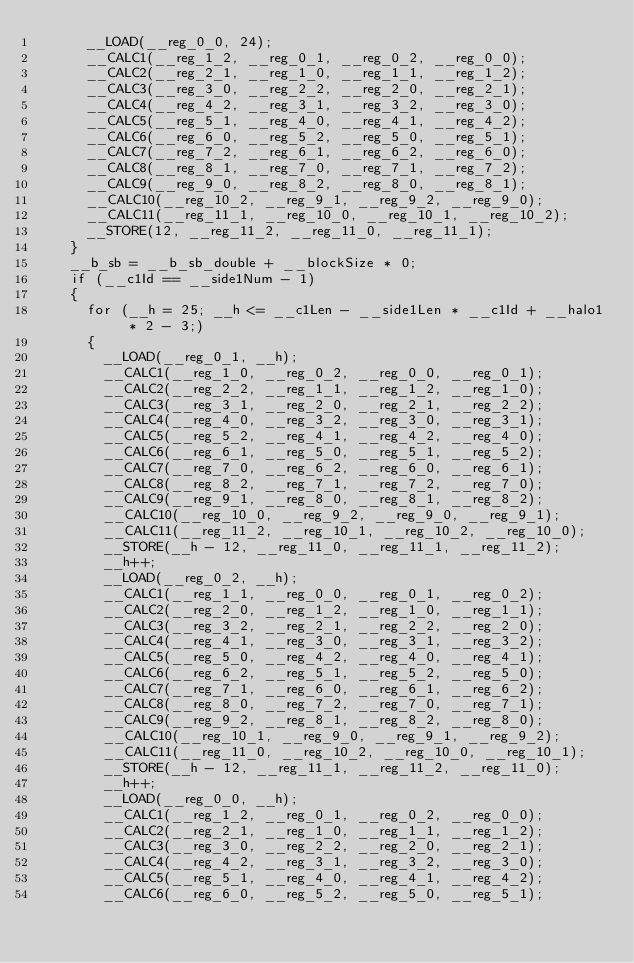<code> <loc_0><loc_0><loc_500><loc_500><_Cuda_>      __LOAD(__reg_0_0, 24);
      __CALC1(__reg_1_2, __reg_0_1, __reg_0_2, __reg_0_0);
      __CALC2(__reg_2_1, __reg_1_0, __reg_1_1, __reg_1_2);
      __CALC3(__reg_3_0, __reg_2_2, __reg_2_0, __reg_2_1);
      __CALC4(__reg_4_2, __reg_3_1, __reg_3_2, __reg_3_0);
      __CALC5(__reg_5_1, __reg_4_0, __reg_4_1, __reg_4_2);
      __CALC6(__reg_6_0, __reg_5_2, __reg_5_0, __reg_5_1);
      __CALC7(__reg_7_2, __reg_6_1, __reg_6_2, __reg_6_0);
      __CALC8(__reg_8_1, __reg_7_0, __reg_7_1, __reg_7_2);
      __CALC9(__reg_9_0, __reg_8_2, __reg_8_0, __reg_8_1);
      __CALC10(__reg_10_2, __reg_9_1, __reg_9_2, __reg_9_0);
      __CALC11(__reg_11_1, __reg_10_0, __reg_10_1, __reg_10_2);
      __STORE(12, __reg_11_2, __reg_11_0, __reg_11_1);
    }
    __b_sb = __b_sb_double + __blockSize * 0;
    if (__c1Id == __side1Num - 1)
    {
      for (__h = 25; __h <= __c1Len - __side1Len * __c1Id + __halo1 * 2 - 3;)
      {
        __LOAD(__reg_0_1, __h);
        __CALC1(__reg_1_0, __reg_0_2, __reg_0_0, __reg_0_1);
        __CALC2(__reg_2_2, __reg_1_1, __reg_1_2, __reg_1_0);
        __CALC3(__reg_3_1, __reg_2_0, __reg_2_1, __reg_2_2);
        __CALC4(__reg_4_0, __reg_3_2, __reg_3_0, __reg_3_1);
        __CALC5(__reg_5_2, __reg_4_1, __reg_4_2, __reg_4_0);
        __CALC6(__reg_6_1, __reg_5_0, __reg_5_1, __reg_5_2);
        __CALC7(__reg_7_0, __reg_6_2, __reg_6_0, __reg_6_1);
        __CALC8(__reg_8_2, __reg_7_1, __reg_7_2, __reg_7_0);
        __CALC9(__reg_9_1, __reg_8_0, __reg_8_1, __reg_8_2);
        __CALC10(__reg_10_0, __reg_9_2, __reg_9_0, __reg_9_1);
        __CALC11(__reg_11_2, __reg_10_1, __reg_10_2, __reg_10_0);
        __STORE(__h - 12, __reg_11_0, __reg_11_1, __reg_11_2);
        __h++;
        __LOAD(__reg_0_2, __h);
        __CALC1(__reg_1_1, __reg_0_0, __reg_0_1, __reg_0_2);
        __CALC2(__reg_2_0, __reg_1_2, __reg_1_0, __reg_1_1);
        __CALC3(__reg_3_2, __reg_2_1, __reg_2_2, __reg_2_0);
        __CALC4(__reg_4_1, __reg_3_0, __reg_3_1, __reg_3_2);
        __CALC5(__reg_5_0, __reg_4_2, __reg_4_0, __reg_4_1);
        __CALC6(__reg_6_2, __reg_5_1, __reg_5_2, __reg_5_0);
        __CALC7(__reg_7_1, __reg_6_0, __reg_6_1, __reg_6_2);
        __CALC8(__reg_8_0, __reg_7_2, __reg_7_0, __reg_7_1);
        __CALC9(__reg_9_2, __reg_8_1, __reg_8_2, __reg_8_0);
        __CALC10(__reg_10_1, __reg_9_0, __reg_9_1, __reg_9_2);
        __CALC11(__reg_11_0, __reg_10_2, __reg_10_0, __reg_10_1);
        __STORE(__h - 12, __reg_11_1, __reg_11_2, __reg_11_0);
        __h++;
        __LOAD(__reg_0_0, __h);
        __CALC1(__reg_1_2, __reg_0_1, __reg_0_2, __reg_0_0);
        __CALC2(__reg_2_1, __reg_1_0, __reg_1_1, __reg_1_2);
        __CALC3(__reg_3_0, __reg_2_2, __reg_2_0, __reg_2_1);
        __CALC4(__reg_4_2, __reg_3_1, __reg_3_2, __reg_3_0);
        __CALC5(__reg_5_1, __reg_4_0, __reg_4_1, __reg_4_2);
        __CALC6(__reg_6_0, __reg_5_2, __reg_5_0, __reg_5_1);</code> 